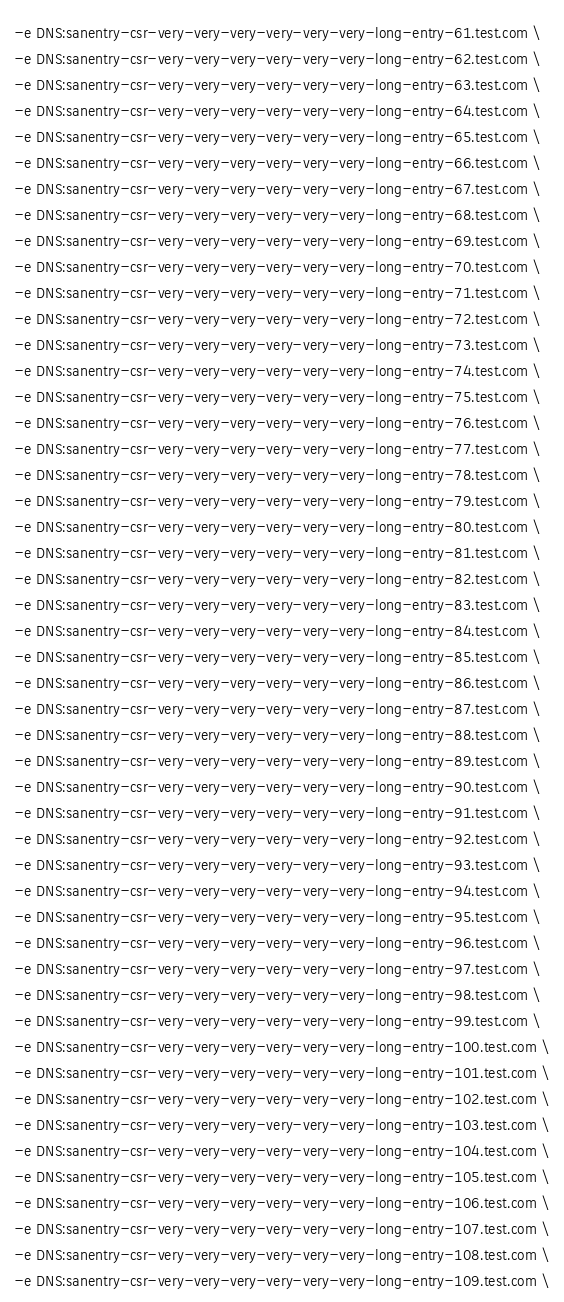<code> <loc_0><loc_0><loc_500><loc_500><_Bash_>-e DNS:sanentry-csr-very-very-very-very-very-very-long-entry-61.test.com \
-e DNS:sanentry-csr-very-very-very-very-very-very-long-entry-62.test.com \
-e DNS:sanentry-csr-very-very-very-very-very-very-long-entry-63.test.com \
-e DNS:sanentry-csr-very-very-very-very-very-very-long-entry-64.test.com \
-e DNS:sanentry-csr-very-very-very-very-very-very-long-entry-65.test.com \
-e DNS:sanentry-csr-very-very-very-very-very-very-long-entry-66.test.com \
-e DNS:sanentry-csr-very-very-very-very-very-very-long-entry-67.test.com \
-e DNS:sanentry-csr-very-very-very-very-very-very-long-entry-68.test.com \
-e DNS:sanentry-csr-very-very-very-very-very-very-long-entry-69.test.com \
-e DNS:sanentry-csr-very-very-very-very-very-very-long-entry-70.test.com \
-e DNS:sanentry-csr-very-very-very-very-very-very-long-entry-71.test.com \
-e DNS:sanentry-csr-very-very-very-very-very-very-long-entry-72.test.com \
-e DNS:sanentry-csr-very-very-very-very-very-very-long-entry-73.test.com \
-e DNS:sanentry-csr-very-very-very-very-very-very-long-entry-74.test.com \
-e DNS:sanentry-csr-very-very-very-very-very-very-long-entry-75.test.com \
-e DNS:sanentry-csr-very-very-very-very-very-very-long-entry-76.test.com \
-e DNS:sanentry-csr-very-very-very-very-very-very-long-entry-77.test.com \
-e DNS:sanentry-csr-very-very-very-very-very-very-long-entry-78.test.com \
-e DNS:sanentry-csr-very-very-very-very-very-very-long-entry-79.test.com \
-e DNS:sanentry-csr-very-very-very-very-very-very-long-entry-80.test.com \
-e DNS:sanentry-csr-very-very-very-very-very-very-long-entry-81.test.com \
-e DNS:sanentry-csr-very-very-very-very-very-very-long-entry-82.test.com \
-e DNS:sanentry-csr-very-very-very-very-very-very-long-entry-83.test.com \
-e DNS:sanentry-csr-very-very-very-very-very-very-long-entry-84.test.com \
-e DNS:sanentry-csr-very-very-very-very-very-very-long-entry-85.test.com \
-e DNS:sanentry-csr-very-very-very-very-very-very-long-entry-86.test.com \
-e DNS:sanentry-csr-very-very-very-very-very-very-long-entry-87.test.com \
-e DNS:sanentry-csr-very-very-very-very-very-very-long-entry-88.test.com \
-e DNS:sanentry-csr-very-very-very-very-very-very-long-entry-89.test.com \
-e DNS:sanentry-csr-very-very-very-very-very-very-long-entry-90.test.com \
-e DNS:sanentry-csr-very-very-very-very-very-very-long-entry-91.test.com \
-e DNS:sanentry-csr-very-very-very-very-very-very-long-entry-92.test.com \
-e DNS:sanentry-csr-very-very-very-very-very-very-long-entry-93.test.com \
-e DNS:sanentry-csr-very-very-very-very-very-very-long-entry-94.test.com \
-e DNS:sanentry-csr-very-very-very-very-very-very-long-entry-95.test.com \
-e DNS:sanentry-csr-very-very-very-very-very-very-long-entry-96.test.com \
-e DNS:sanentry-csr-very-very-very-very-very-very-long-entry-97.test.com \
-e DNS:sanentry-csr-very-very-very-very-very-very-long-entry-98.test.com \
-e DNS:sanentry-csr-very-very-very-very-very-very-long-entry-99.test.com \
-e DNS:sanentry-csr-very-very-very-very-very-very-long-entry-100.test.com \
-e DNS:sanentry-csr-very-very-very-very-very-very-long-entry-101.test.com \
-e DNS:sanentry-csr-very-very-very-very-very-very-long-entry-102.test.com \
-e DNS:sanentry-csr-very-very-very-very-very-very-long-entry-103.test.com \
-e DNS:sanentry-csr-very-very-very-very-very-very-long-entry-104.test.com \
-e DNS:sanentry-csr-very-very-very-very-very-very-long-entry-105.test.com \
-e DNS:sanentry-csr-very-very-very-very-very-very-long-entry-106.test.com \
-e DNS:sanentry-csr-very-very-very-very-very-very-long-entry-107.test.com \
-e DNS:sanentry-csr-very-very-very-very-very-very-long-entry-108.test.com \
-e DNS:sanentry-csr-very-very-very-very-very-very-long-entry-109.test.com \</code> 